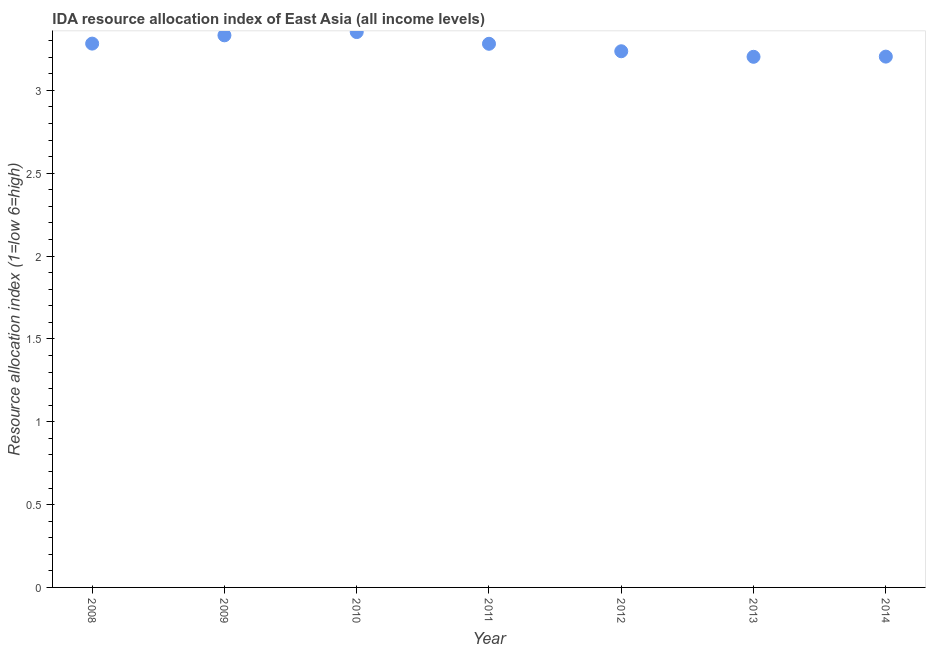What is the ida resource allocation index in 2008?
Keep it short and to the point. 3.28. Across all years, what is the maximum ida resource allocation index?
Provide a short and direct response. 3.35. Across all years, what is the minimum ida resource allocation index?
Offer a terse response. 3.2. In which year was the ida resource allocation index maximum?
Your answer should be compact. 2010. What is the sum of the ida resource allocation index?
Keep it short and to the point. 22.89. What is the difference between the ida resource allocation index in 2009 and 2014?
Your answer should be compact. 0.13. What is the average ida resource allocation index per year?
Your response must be concise. 3.27. What is the median ida resource allocation index?
Give a very brief answer. 3.28. Do a majority of the years between 2009 and 2012 (inclusive) have ida resource allocation index greater than 2.4 ?
Give a very brief answer. Yes. What is the ratio of the ida resource allocation index in 2009 to that in 2011?
Ensure brevity in your answer.  1.02. Is the difference between the ida resource allocation index in 2009 and 2014 greater than the difference between any two years?
Offer a very short reply. No. What is the difference between the highest and the second highest ida resource allocation index?
Your response must be concise. 0.02. What is the difference between the highest and the lowest ida resource allocation index?
Make the answer very short. 0.15. In how many years, is the ida resource allocation index greater than the average ida resource allocation index taken over all years?
Offer a terse response. 4. What is the difference between two consecutive major ticks on the Y-axis?
Your answer should be compact. 0.5. Does the graph contain any zero values?
Ensure brevity in your answer.  No. Does the graph contain grids?
Give a very brief answer. No. What is the title of the graph?
Your answer should be compact. IDA resource allocation index of East Asia (all income levels). What is the label or title of the X-axis?
Your answer should be very brief. Year. What is the label or title of the Y-axis?
Offer a very short reply. Resource allocation index (1=low 6=high). What is the Resource allocation index (1=low 6=high) in 2008?
Your response must be concise. 3.28. What is the Resource allocation index (1=low 6=high) in 2009?
Your answer should be compact. 3.33. What is the Resource allocation index (1=low 6=high) in 2010?
Your response must be concise. 3.35. What is the Resource allocation index (1=low 6=high) in 2011?
Provide a succinct answer. 3.28. What is the Resource allocation index (1=low 6=high) in 2012?
Your response must be concise. 3.24. What is the Resource allocation index (1=low 6=high) in 2013?
Your answer should be very brief. 3.2. What is the Resource allocation index (1=low 6=high) in 2014?
Provide a short and direct response. 3.2. What is the difference between the Resource allocation index (1=low 6=high) in 2008 and 2010?
Provide a succinct answer. -0.07. What is the difference between the Resource allocation index (1=low 6=high) in 2008 and 2011?
Give a very brief answer. 0. What is the difference between the Resource allocation index (1=low 6=high) in 2008 and 2012?
Give a very brief answer. 0.05. What is the difference between the Resource allocation index (1=low 6=high) in 2008 and 2013?
Provide a succinct answer. 0.08. What is the difference between the Resource allocation index (1=low 6=high) in 2008 and 2014?
Provide a succinct answer. 0.08. What is the difference between the Resource allocation index (1=low 6=high) in 2009 and 2010?
Provide a succinct answer. -0.02. What is the difference between the Resource allocation index (1=low 6=high) in 2009 and 2011?
Make the answer very short. 0.05. What is the difference between the Resource allocation index (1=low 6=high) in 2009 and 2012?
Ensure brevity in your answer.  0.1. What is the difference between the Resource allocation index (1=low 6=high) in 2009 and 2013?
Offer a very short reply. 0.13. What is the difference between the Resource allocation index (1=low 6=high) in 2009 and 2014?
Offer a terse response. 0.13. What is the difference between the Resource allocation index (1=low 6=high) in 2010 and 2011?
Give a very brief answer. 0.07. What is the difference between the Resource allocation index (1=low 6=high) in 2010 and 2012?
Ensure brevity in your answer.  0.12. What is the difference between the Resource allocation index (1=low 6=high) in 2010 and 2013?
Your response must be concise. 0.15. What is the difference between the Resource allocation index (1=low 6=high) in 2010 and 2014?
Ensure brevity in your answer.  0.15. What is the difference between the Resource allocation index (1=low 6=high) in 2011 and 2012?
Ensure brevity in your answer.  0.05. What is the difference between the Resource allocation index (1=low 6=high) in 2011 and 2013?
Keep it short and to the point. 0.08. What is the difference between the Resource allocation index (1=low 6=high) in 2011 and 2014?
Offer a terse response. 0.08. What is the difference between the Resource allocation index (1=low 6=high) in 2012 and 2013?
Offer a very short reply. 0.03. What is the difference between the Resource allocation index (1=low 6=high) in 2012 and 2014?
Provide a succinct answer. 0.03. What is the difference between the Resource allocation index (1=low 6=high) in 2013 and 2014?
Offer a very short reply. -0. What is the ratio of the Resource allocation index (1=low 6=high) in 2008 to that in 2010?
Make the answer very short. 0.98. What is the ratio of the Resource allocation index (1=low 6=high) in 2008 to that in 2012?
Offer a very short reply. 1.01. What is the ratio of the Resource allocation index (1=low 6=high) in 2009 to that in 2012?
Provide a short and direct response. 1.03. What is the ratio of the Resource allocation index (1=low 6=high) in 2009 to that in 2013?
Provide a succinct answer. 1.04. What is the ratio of the Resource allocation index (1=low 6=high) in 2009 to that in 2014?
Ensure brevity in your answer.  1.04. What is the ratio of the Resource allocation index (1=low 6=high) in 2010 to that in 2012?
Ensure brevity in your answer.  1.04. What is the ratio of the Resource allocation index (1=low 6=high) in 2010 to that in 2013?
Offer a terse response. 1.05. What is the ratio of the Resource allocation index (1=low 6=high) in 2010 to that in 2014?
Provide a succinct answer. 1.05. What is the ratio of the Resource allocation index (1=low 6=high) in 2011 to that in 2013?
Offer a very short reply. 1.02. What is the ratio of the Resource allocation index (1=low 6=high) in 2012 to that in 2014?
Your response must be concise. 1.01. 